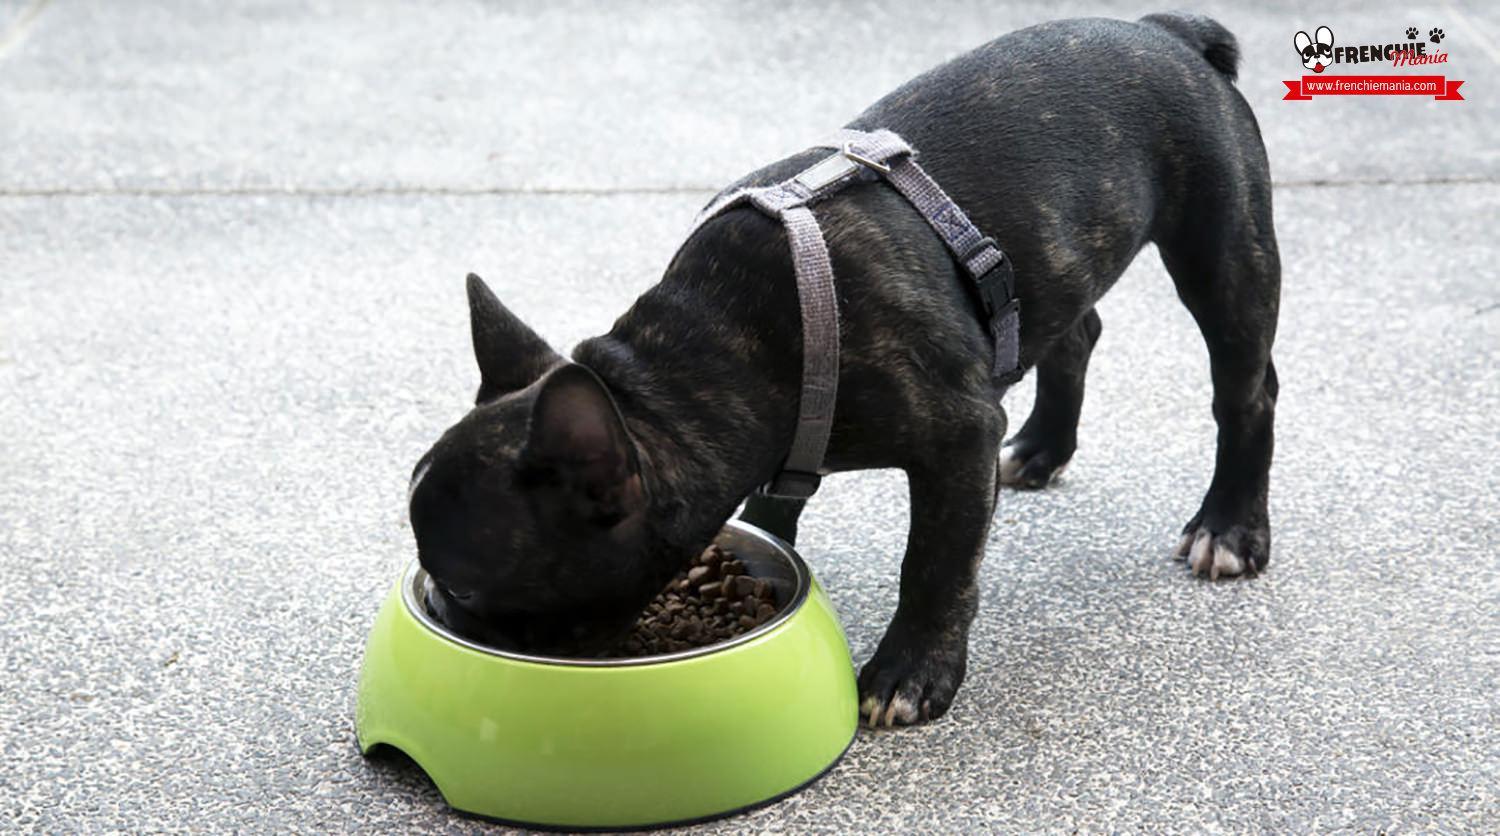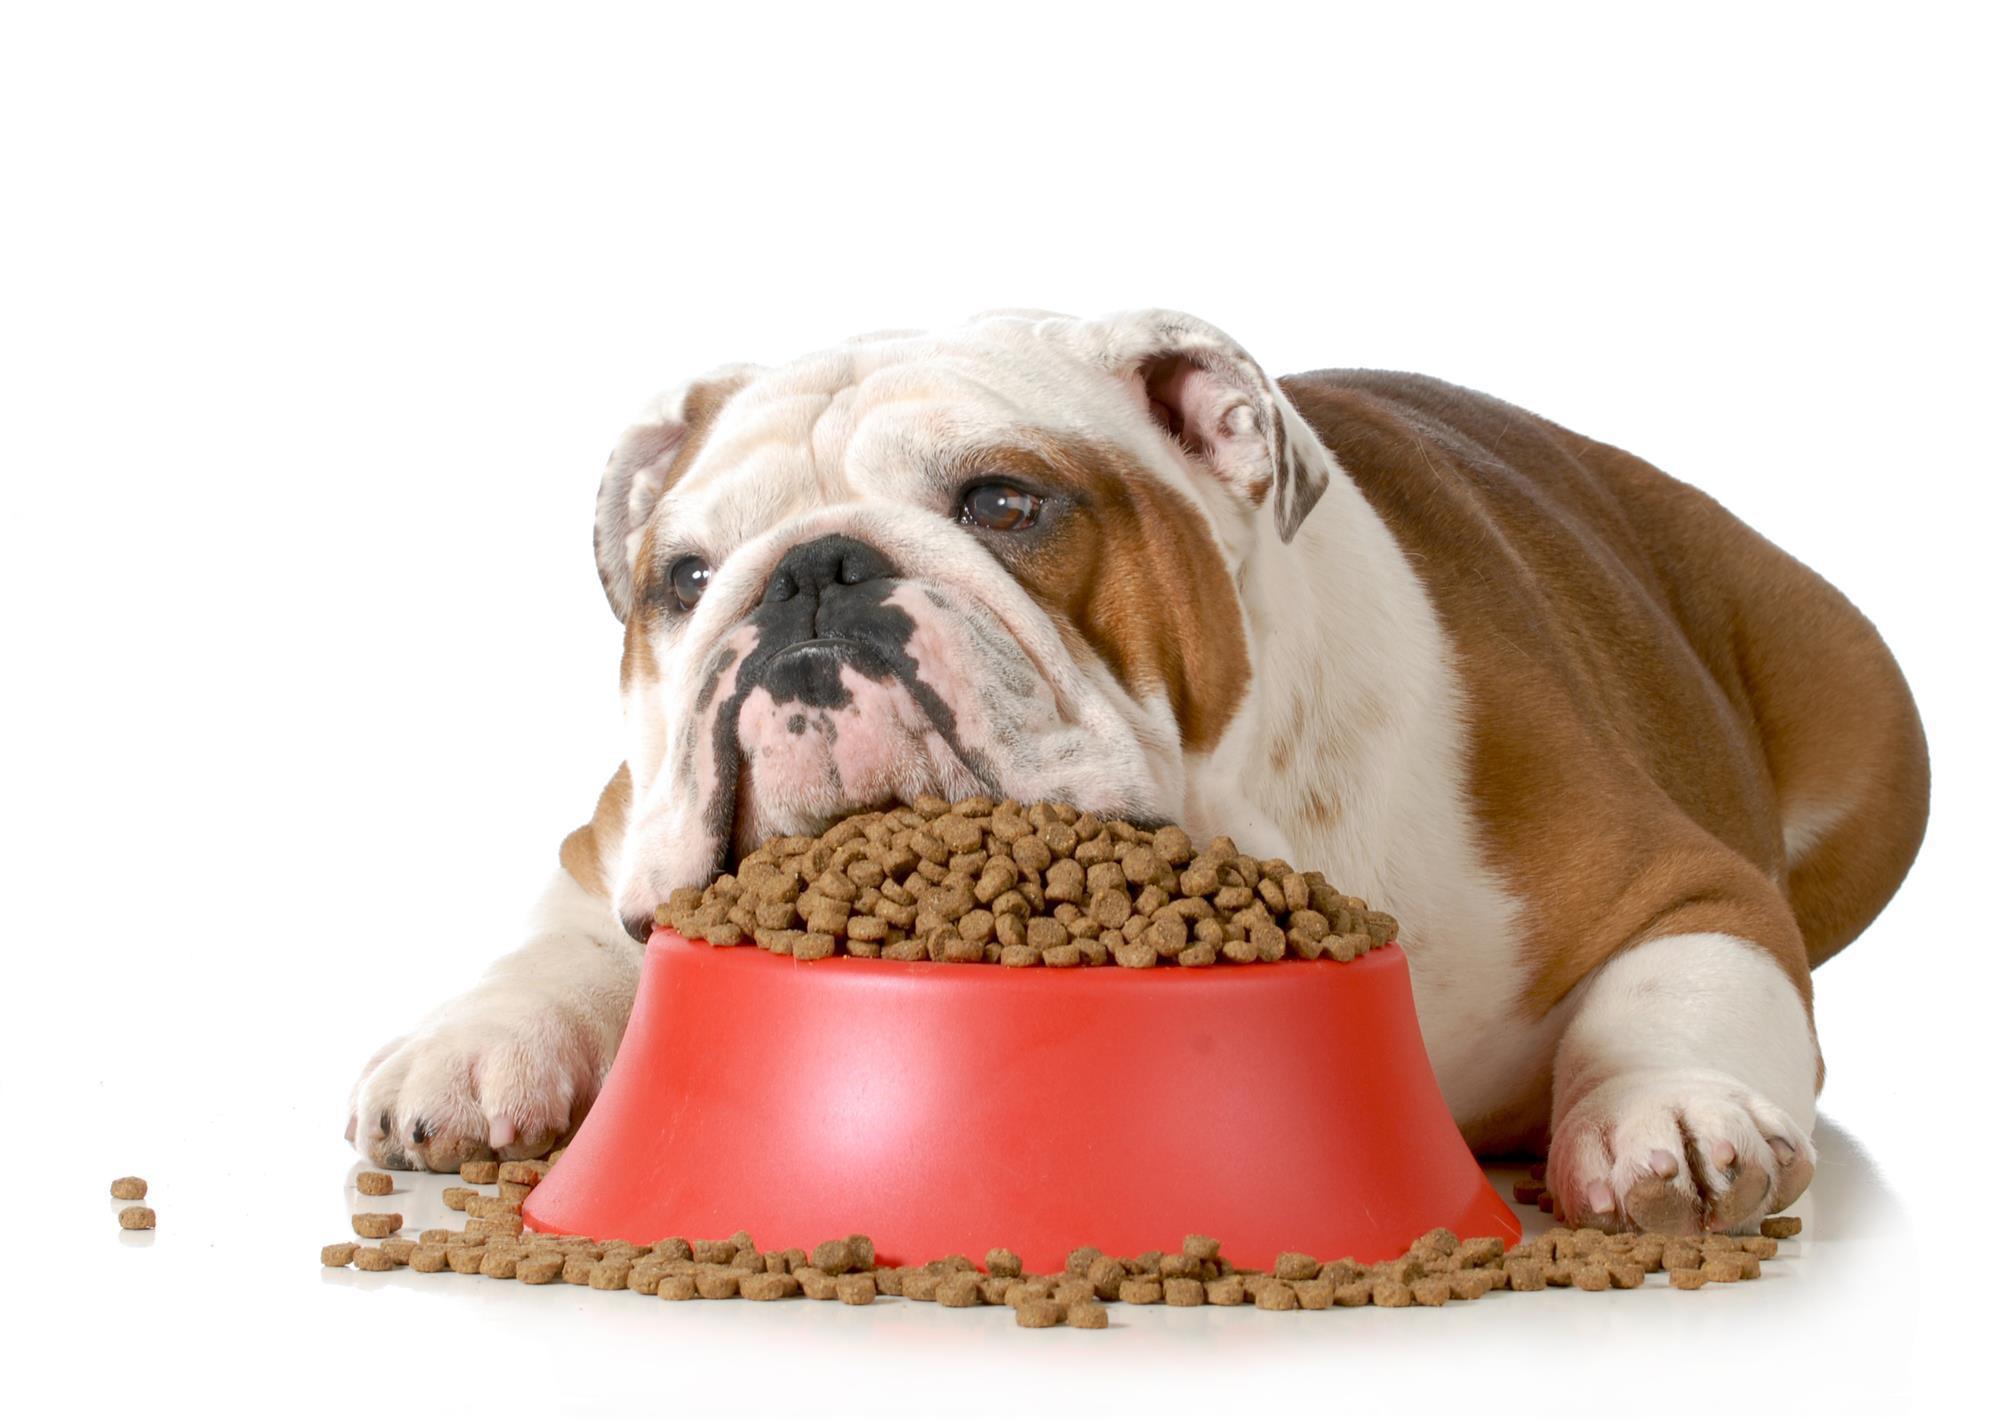The first image is the image on the left, the second image is the image on the right. Assess this claim about the two images: "Each image shows a dog with a food bowl in front of it.". Correct or not? Answer yes or no. Yes. The first image is the image on the left, the second image is the image on the right. Examine the images to the left and right. Is the description "In at least one image ther is a small black puppy in a grey harness eating out of a green bowl." accurate? Answer yes or no. Yes. 